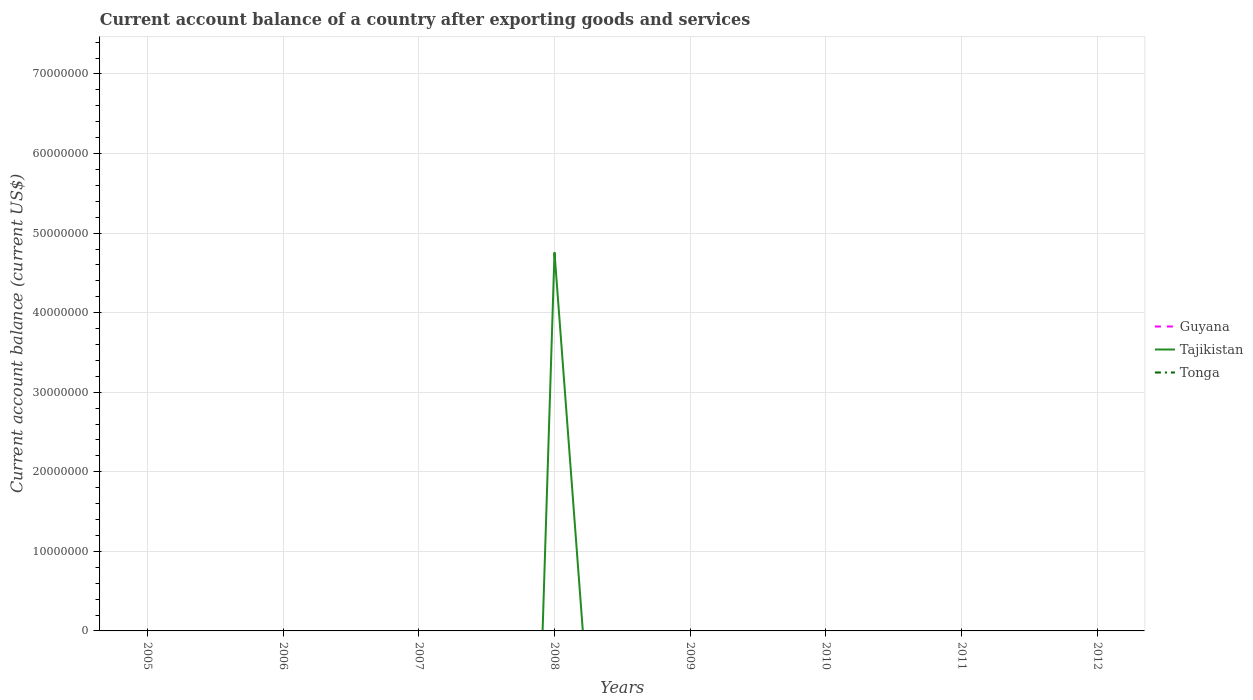How many different coloured lines are there?
Ensure brevity in your answer.  1. Does the line corresponding to Tajikistan intersect with the line corresponding to Tonga?
Your answer should be compact. Yes. Across all years, what is the maximum account balance in Guyana?
Provide a short and direct response. 0. What is the difference between the highest and the second highest account balance in Tajikistan?
Keep it short and to the point. 4.76e+07. How many lines are there?
Give a very brief answer. 1. Are the values on the major ticks of Y-axis written in scientific E-notation?
Your response must be concise. No. How are the legend labels stacked?
Your answer should be very brief. Vertical. What is the title of the graph?
Provide a short and direct response. Current account balance of a country after exporting goods and services. Does "American Samoa" appear as one of the legend labels in the graph?
Your response must be concise. No. What is the label or title of the Y-axis?
Offer a terse response. Current account balance (current US$). What is the Current account balance (current US$) in Guyana in 2005?
Ensure brevity in your answer.  0. What is the Current account balance (current US$) of Tajikistan in 2005?
Offer a terse response. 0. What is the Current account balance (current US$) of Guyana in 2006?
Provide a succinct answer. 0. What is the Current account balance (current US$) in Tajikistan in 2007?
Provide a short and direct response. 0. What is the Current account balance (current US$) in Tonga in 2007?
Offer a very short reply. 0. What is the Current account balance (current US$) of Guyana in 2008?
Offer a very short reply. 0. What is the Current account balance (current US$) in Tajikistan in 2008?
Your answer should be compact. 4.76e+07. What is the Current account balance (current US$) in Tonga in 2008?
Give a very brief answer. 0. What is the Current account balance (current US$) in Guyana in 2009?
Make the answer very short. 0. What is the Current account balance (current US$) in Tajikistan in 2009?
Your response must be concise. 0. What is the Current account balance (current US$) in Tonga in 2009?
Your answer should be compact. 0. What is the Current account balance (current US$) of Tonga in 2010?
Give a very brief answer. 0. What is the Current account balance (current US$) in Guyana in 2011?
Your answer should be compact. 0. What is the Current account balance (current US$) of Tonga in 2011?
Your answer should be very brief. 0. What is the Current account balance (current US$) in Guyana in 2012?
Your answer should be compact. 0. What is the Current account balance (current US$) in Tajikistan in 2012?
Offer a very short reply. 0. Across all years, what is the maximum Current account balance (current US$) of Tajikistan?
Your answer should be compact. 4.76e+07. What is the total Current account balance (current US$) in Tajikistan in the graph?
Offer a terse response. 4.76e+07. What is the average Current account balance (current US$) of Guyana per year?
Keep it short and to the point. 0. What is the average Current account balance (current US$) of Tajikistan per year?
Provide a short and direct response. 5.95e+06. What is the average Current account balance (current US$) of Tonga per year?
Give a very brief answer. 0. What is the difference between the highest and the lowest Current account balance (current US$) of Tajikistan?
Give a very brief answer. 4.76e+07. 